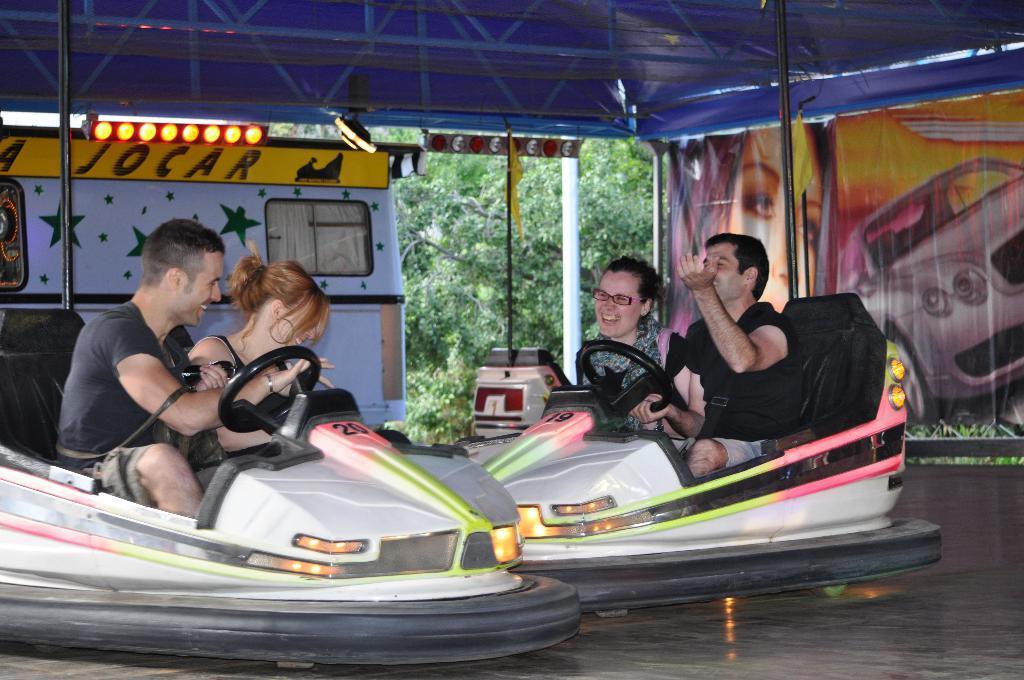Describe this image in one or two sentences. In this picture there are people sitting in vehicles and we can see poles, boards, banner, lights, shed and objects. In the background of the image we can see leaves. 